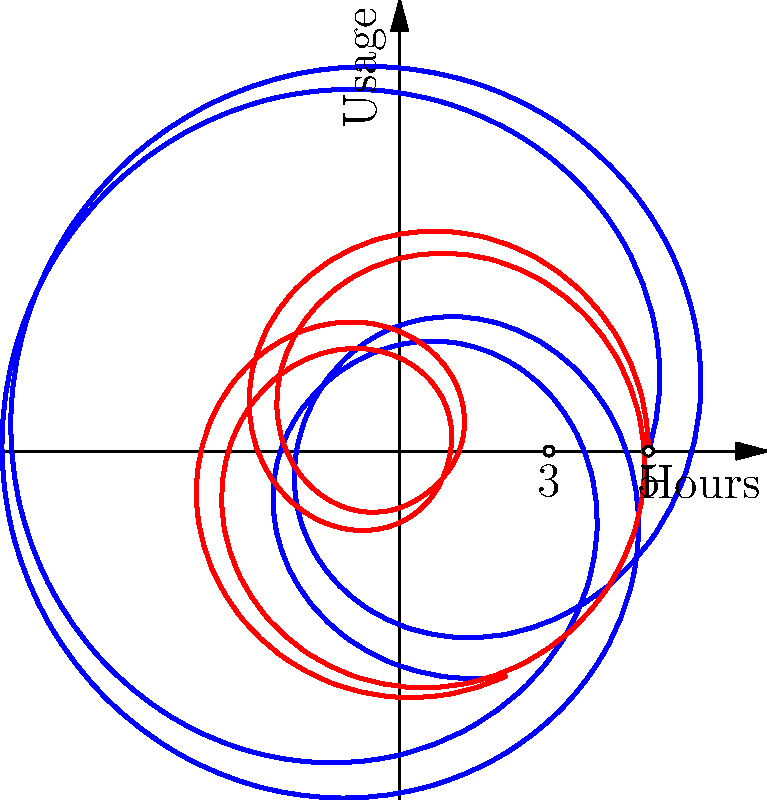As a school principal concerned with media literacy, you're analyzing social media usage trends among students. The polar graph shows the usage patterns of two social media platforms over a 24-hour period. The radial distance represents the number of active users, and the angle represents the time of day (with 0° corresponding to midnight). Which platform experiences more significant fluctuations in user activity throughout the day, and what might this imply for student engagement with digital media? To answer this question, let's analyze the graph step-by-step:

1. Identify the two curves:
   - Blue curve represents Social Media Platform A
   - Red curve represents Social Media Platform B

2. Observe the basic shape and position of each curve:
   - Platform A's curve (blue) is centered around 5 units from the origin
   - Platform B's curve (red) is centered around 3 units from the origin

3. Analyze the fluctuations:
   - Platform A's curve shows larger variations in radial distance
   - Platform B's curve shows smaller variations in radial distance

4. Calculate the amplitude of fluctuations:
   - Platform A: The curve varies by approximately 3 units (from about 2 to 8)
   - Platform B: The curve varies by approximately 2 units (from about 1 to 5)

5. Compare the relative fluctuations:
   - Platform A's fluctuation (3 units) is 60% of its average value (5 units)
   - Platform B's fluctuation (2 units) is about 67% of its average value (3 units)

6. Interpret the results:
   - While Platform B has a slightly higher relative fluctuation, Platform A shows larger absolute changes in user numbers throughout the day

7. Consider implications for student engagement:
   - Platform A's larger absolute fluctuations suggest more dramatic changes in user activity, which could indicate:
     a) More defined peak usage times
     b) Potentially more addictive or habit-forming features
     c) Greater impact on students' daily routines and time management

Therefore, Platform A experiences more significant fluctuations in absolute terms, implying that it may have a more pronounced effect on students' daily digital media engagement patterns.
Answer: Platform A; larger absolute fluctuations suggest more defined usage patterns and potentially greater impact on students' daily digital engagement. 